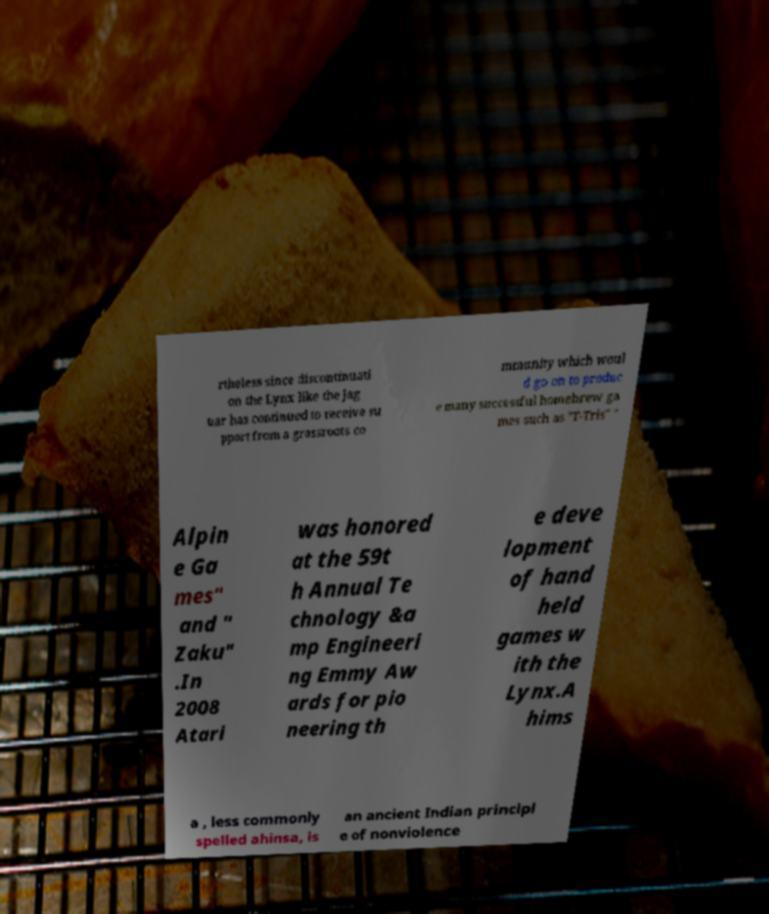Please read and relay the text visible in this image. What does it say? rtheless since discontinuati on the Lynx like the Jag uar has continued to receive su pport from a grassroots co mmunity which woul d go on to produc e many successful homebrew ga mes such as "T-Tris" " Alpin e Ga mes" and " Zaku" .In 2008 Atari was honored at the 59t h Annual Te chnology &a mp Engineeri ng Emmy Aw ards for pio neering th e deve lopment of hand held games w ith the Lynx.A hims a , less commonly spelled ahinsa, is an ancient Indian principl e of nonviolence 